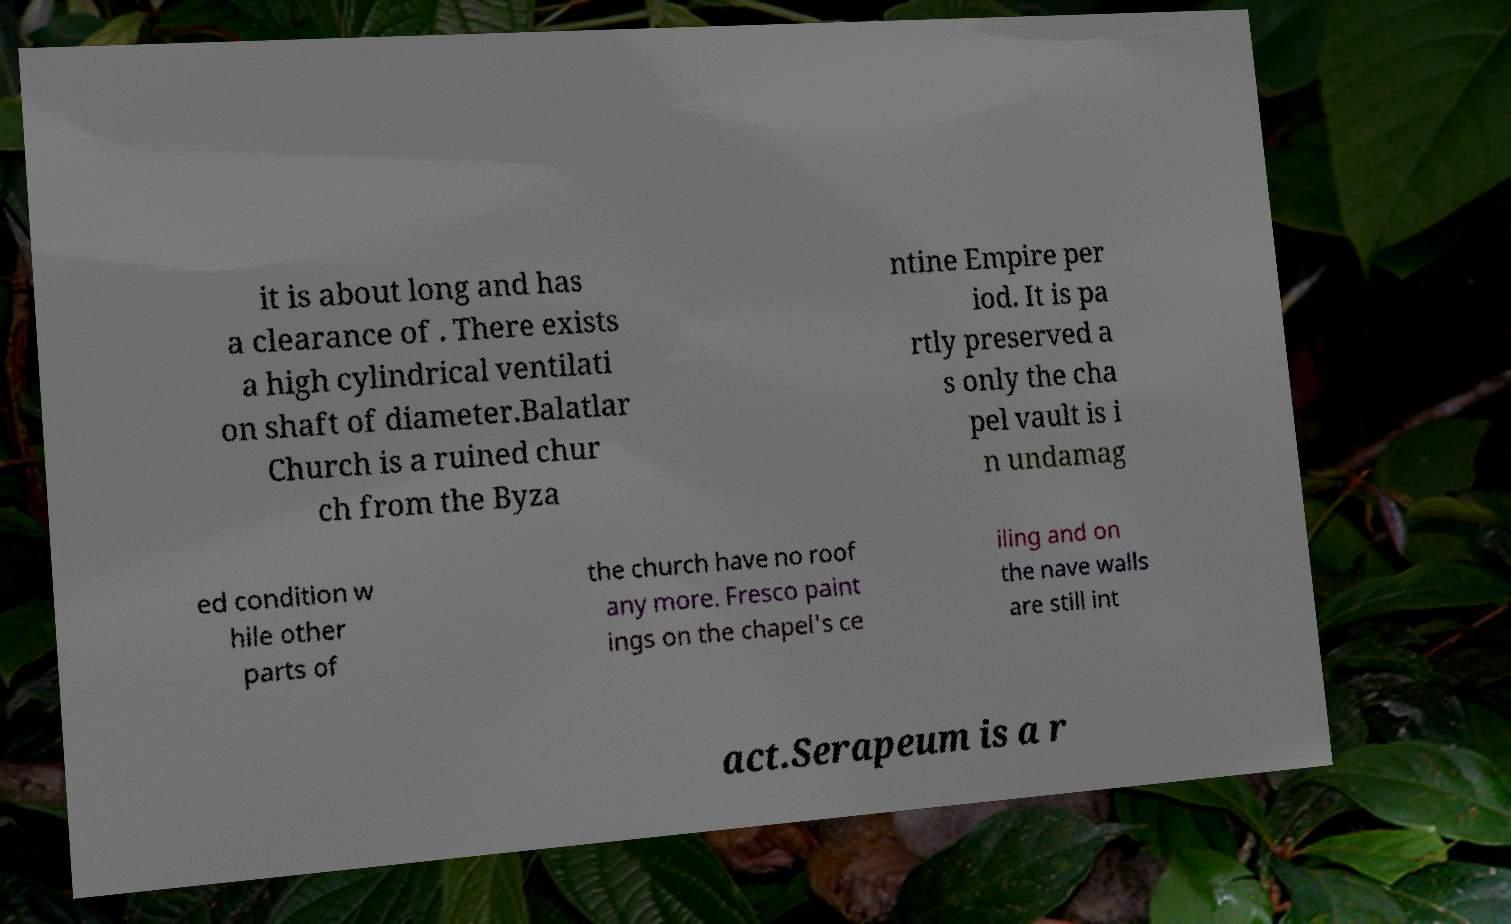Please read and relay the text visible in this image. What does it say? it is about long and has a clearance of . There exists a high cylindrical ventilati on shaft of diameter.Balatlar Church is a ruined chur ch from the Byza ntine Empire per iod. It is pa rtly preserved a s only the cha pel vault is i n undamag ed condition w hile other parts of the church have no roof any more. Fresco paint ings on the chapel's ce iling and on the nave walls are still int act.Serapeum is a r 